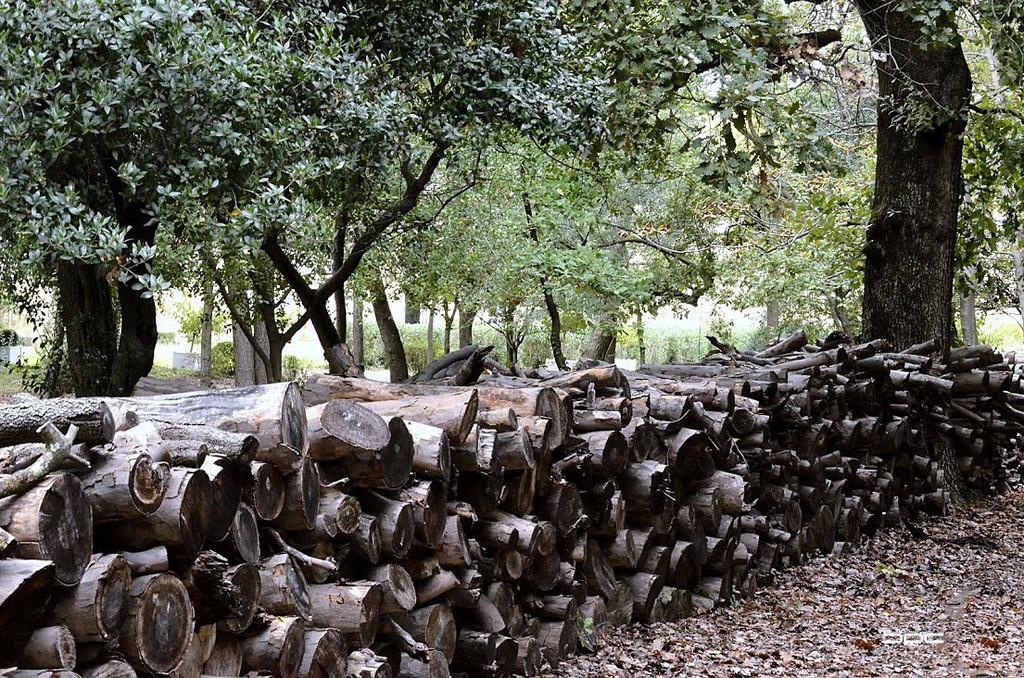What is on the ground in the image? There are wooden logs and dried leaves on the ground in the image. What can be seen in the background of the image? Plants and trees are visible in the background of the image. How many pieces of cheese can be seen in the image? There is no cheese present in the image. What type of teeth can be seen in the image? There are no teeth visible in the image. 